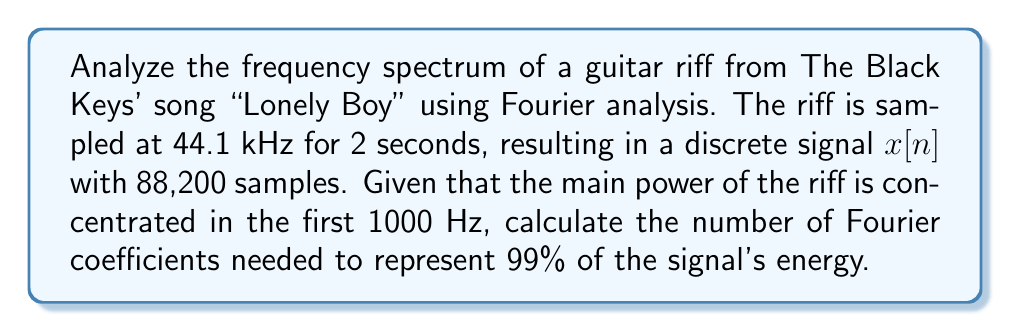Could you help me with this problem? To solve this problem, we'll follow these steps:

1) First, we need to understand the relationship between the sampling frequency and the Nyquist frequency:

   Nyquist frequency = Sampling frequency / 2 = 44.1 kHz / 2 = 22.05 kHz

2) The Discrete Fourier Transform (DFT) of the signal will have N = 88,200 coefficients, corresponding to frequencies from 0 to 44.1 kHz.

3) Each DFT coefficient represents a frequency bin with width:

   $$\Delta f = \frac{f_s}{N} = \frac{44100}{88200} = 0.5 \text{ Hz}$$

4) The number of coefficients needed to represent the first 1000 Hz is:

   $$k = \frac{1000 \text{ Hz}}{0.5 \text{ Hz/coefficient}} = 2000 \text{ coefficients}$$

5) However, due to the symmetry of the DFT for real signals, we only need half of these coefficients:

   $$k = 2000 / 2 = 1000 \text{ coefficients}$$

6) To ensure we capture 99% of the signal's energy, we should include a safety margin. A common practice is to use about 10% more coefficients:

   $$k_{final} = 1000 * 1.1 \approx 1100 \text{ coefficients}$$

This number of coefficients should be sufficient to represent 99% of the signal's energy, given that the main power of the riff is concentrated in the first 1000 Hz.
Answer: 1100 coefficients 